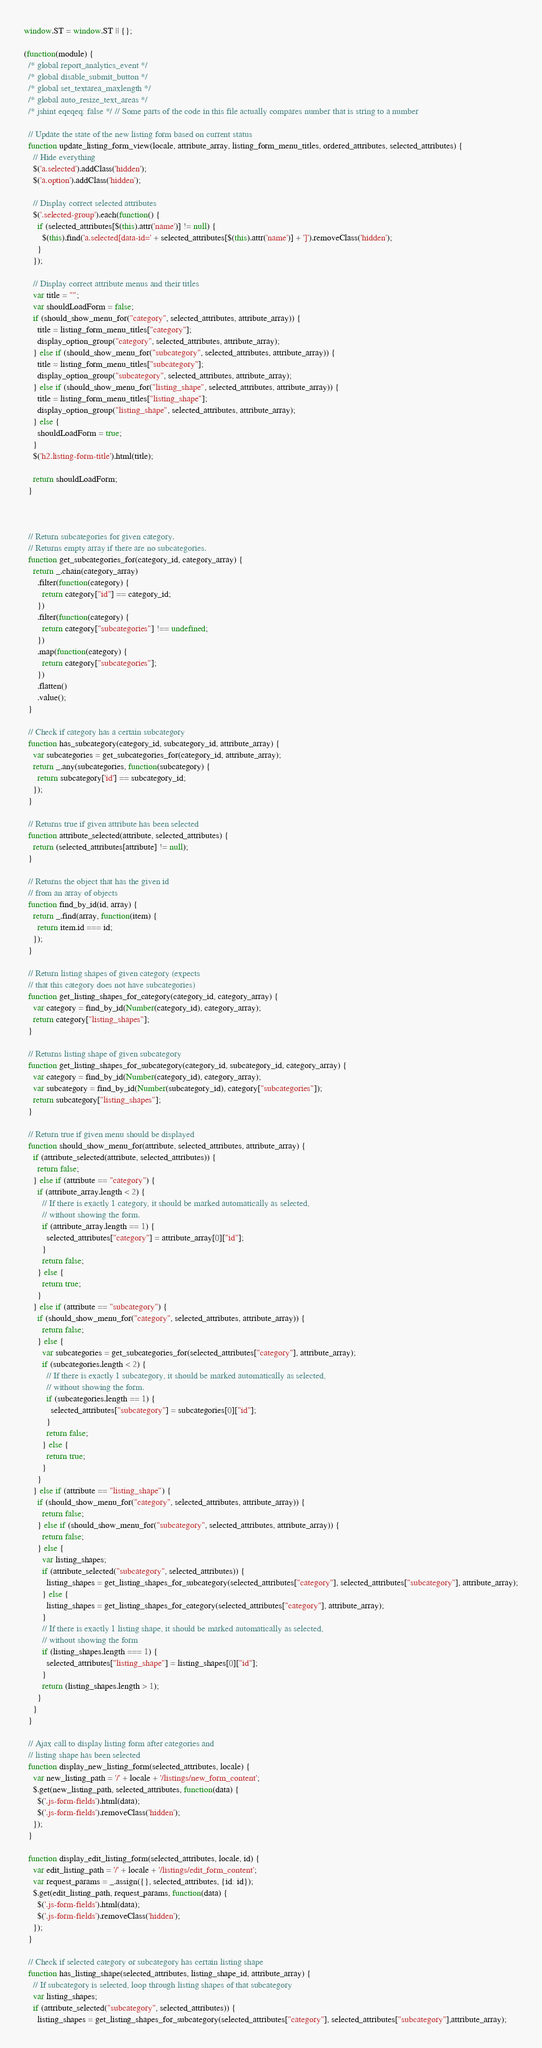<code> <loc_0><loc_0><loc_500><loc_500><_JavaScript_>window.ST = window.ST || {};

(function(module) {
  /* global report_analytics_event */
  /* global disable_submit_button */
  /* global set_textarea_maxlength */
  /* global auto_resize_text_areas */
  /* jshint eqeqeq: false */ // Some parts of the code in this file actually compares number that is string to a number

  // Update the state of the new listing form based on current status
  function update_listing_form_view(locale, attribute_array, listing_form_menu_titles, ordered_attributes, selected_attributes) {
    // Hide everything
    $('a.selected').addClass('hidden');
    $('a.option').addClass('hidden');

    // Display correct selected attributes
    $('.selected-group').each(function() {
      if (selected_attributes[$(this).attr('name')] != null) {
        $(this).find('a.selected[data-id=' + selected_attributes[$(this).attr('name')] + ']').removeClass('hidden');
      }
    });

    // Display correct attribute menus and their titles
    var title = "";
    var shouldLoadForm = false;
    if (should_show_menu_for("category", selected_attributes, attribute_array)) {
      title = listing_form_menu_titles["category"];
      display_option_group("category", selected_attributes, attribute_array);
    } else if (should_show_menu_for("subcategory", selected_attributes, attribute_array)) {
      title = listing_form_menu_titles["subcategory"];
      display_option_group("subcategory", selected_attributes, attribute_array);
    } else if (should_show_menu_for("listing_shape", selected_attributes, attribute_array)) {
      title = listing_form_menu_titles["listing_shape"];
      display_option_group("listing_shape", selected_attributes, attribute_array);
    } else {
      shouldLoadForm = true;
    }
    $('h2.listing-form-title').html(title);

    return shouldLoadForm;
  }



  // Return subcategories for given category.
  // Returns empty array if there are no subcategories.
  function get_subcategories_for(category_id, category_array) {
    return _.chain(category_array)
      .filter(function(category) {
        return category["id"] == category_id;
      })
      .filter(function(category) {
        return category["subcategories"] !== undefined;
      })
      .map(function(category) {
        return category["subcategories"];
      })
      .flatten()
      .value();
  }

  // Check if category has a certain subcategory
  function has_subcategory(category_id, subcategory_id, attribute_array) {
    var subcategories = get_subcategories_for(category_id, attribute_array);
    return _.any(subcategories, function(subcategory) {
      return subcategory['id'] == subcategory_id;
    });
  }

  // Returns true if given attribute has been selected
  function attribute_selected(attribute, selected_attributes) {
    return (selected_attributes[attribute] != null);
  }

  // Returns the object that has the given id
  // from an array of objects
  function find_by_id(id, array) {
    return _.find(array, function(item) {
      return item.id === id;
    });
  }

  // Return listing shapes of given category (expects
  // that this category does not have subcategories)
  function get_listing_shapes_for_category(category_id, category_array) {
    var category = find_by_id(Number(category_id), category_array);
    return category["listing_shapes"];
  }

  // Returns listing shape of given subcategory
  function get_listing_shapes_for_subcategory(category_id, subcategory_id, category_array) {
    var category = find_by_id(Number(category_id), category_array);
    var subcategory = find_by_id(Number(subcategory_id), category["subcategories"]);
    return subcategory["listing_shapes"];
  }

  // Return true if given menu should be displayed
  function should_show_menu_for(attribute, selected_attributes, attribute_array) {
    if (attribute_selected(attribute, selected_attributes)) {
      return false;
    } else if (attribute == "category") {
      if (attribute_array.length < 2) {
        // If there is exactly 1 category, it should be marked automatically as selected,
        // without showing the form.
        if (attribute_array.length == 1) {
          selected_attributes["category"] = attribute_array[0]["id"];
        }
        return false;
      } else {
        return true;
      }
    } else if (attribute == "subcategory") {
      if (should_show_menu_for("category", selected_attributes, attribute_array)) {
        return false;
      } else {
        var subcategories = get_subcategories_for(selected_attributes["category"], attribute_array);
        if (subcategories.length < 2) {
          // If there is exactly 1 subcategory, it should be marked automatically as selected,
          // without showing the form.
          if (subcategories.length == 1) {
            selected_attributes["subcategory"] = subcategories[0]["id"];
          }
          return false;
        } else {
          return true;
        }
      }
    } else if (attribute == "listing_shape") {
      if (should_show_menu_for("category", selected_attributes, attribute_array)) {
        return false;
      } else if (should_show_menu_for("subcategory", selected_attributes, attribute_array)) {
        return false;
      } else {
        var listing_shapes;
        if (attribute_selected("subcategory", selected_attributes)) {
          listing_shapes = get_listing_shapes_for_subcategory(selected_attributes["category"], selected_attributes["subcategory"], attribute_array);
        } else {
          listing_shapes = get_listing_shapes_for_category(selected_attributes["category"], attribute_array);
        }
        // If there is exactly 1 listing shape, it should be marked automatically as selected,
        // without showing the form
        if (listing_shapes.length === 1) {
          selected_attributes["listing_shape"] = listing_shapes[0]["id"];
        }
        return (listing_shapes.length > 1);
      }
    }
  }

  // Ajax call to display listing form after categories and
  // listing shape has been selected
  function display_new_listing_form(selected_attributes, locale) {
    var new_listing_path = '/' + locale + '/listings/new_form_content';
    $.get(new_listing_path, selected_attributes, function(data) {
      $('.js-form-fields').html(data);
      $('.js-form-fields').removeClass('hidden');
    });
  }

  function display_edit_listing_form(selected_attributes, locale, id) {
    var edit_listing_path = '/' + locale + '/listings/edit_form_content';
    var request_params = _.assign({}, selected_attributes, {id: id});
    $.get(edit_listing_path, request_params, function(data) {
      $('.js-form-fields').html(data);
      $('.js-form-fields').removeClass('hidden');
    });
  }

  // Check if selected category or subcategory has certain listing shape
  function has_listing_shape(selected_attributes, listing_shape_id, attribute_array) {
    // If subcategory is selected, loop through listing shapes of that subcategory
    var listing_shapes;
    if (attribute_selected("subcategory", selected_attributes)) {
      listing_shapes = get_listing_shapes_for_subcategory(selected_attributes["category"], selected_attributes["subcategory"],attribute_array);</code> 